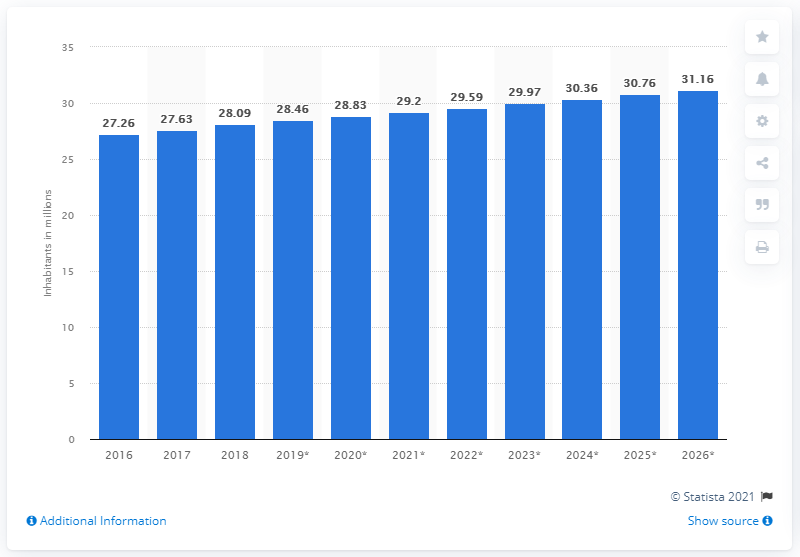Identify some key points in this picture. The total population of Nepal in 2018 was 28.09 million. 